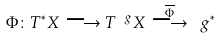Convert formula to latex. <formula><loc_0><loc_0><loc_500><loc_500>\Phi \colon T ^ { * } X \longrightarrow T ^ { \ g } X \stackrel { \overline { \Phi } } { \longrightarrow } \ g ^ { * }</formula> 